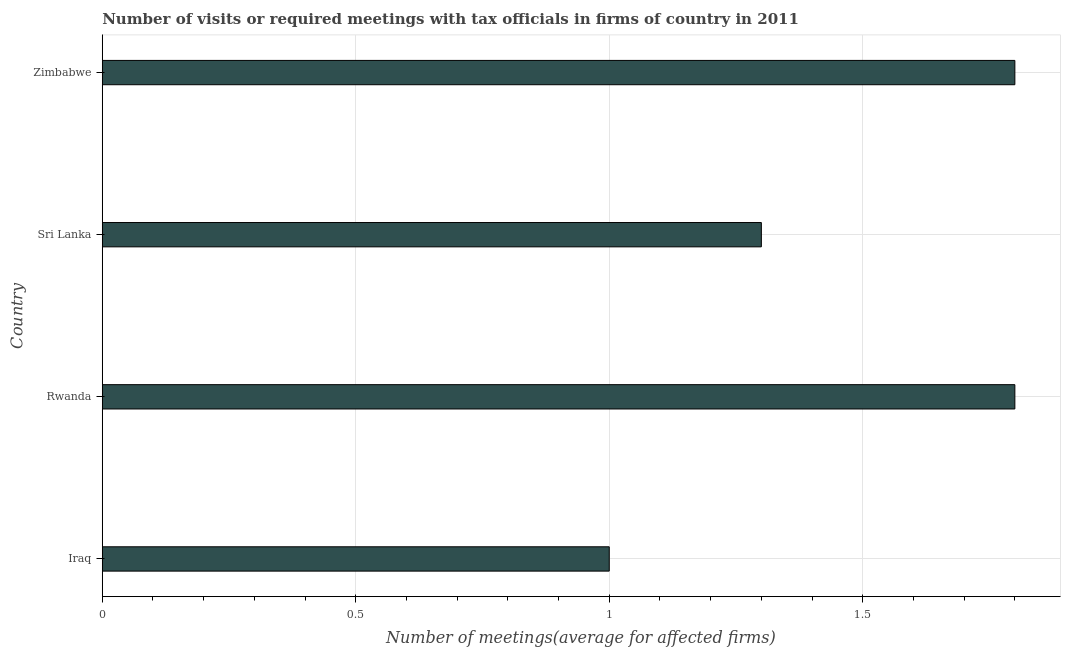Does the graph contain any zero values?
Provide a short and direct response. No. What is the title of the graph?
Your answer should be compact. Number of visits or required meetings with tax officials in firms of country in 2011. What is the label or title of the X-axis?
Keep it short and to the point. Number of meetings(average for affected firms). Across all countries, what is the minimum number of required meetings with tax officials?
Your answer should be compact. 1. In which country was the number of required meetings with tax officials maximum?
Your answer should be very brief. Rwanda. In which country was the number of required meetings with tax officials minimum?
Give a very brief answer. Iraq. What is the sum of the number of required meetings with tax officials?
Give a very brief answer. 5.9. What is the average number of required meetings with tax officials per country?
Your answer should be compact. 1.48. What is the median number of required meetings with tax officials?
Give a very brief answer. 1.55. What is the ratio of the number of required meetings with tax officials in Iraq to that in Rwanda?
Provide a short and direct response. 0.56. What is the difference between the highest and the second highest number of required meetings with tax officials?
Offer a very short reply. 0. Is the sum of the number of required meetings with tax officials in Iraq and Zimbabwe greater than the maximum number of required meetings with tax officials across all countries?
Give a very brief answer. Yes. In how many countries, is the number of required meetings with tax officials greater than the average number of required meetings with tax officials taken over all countries?
Your response must be concise. 2. How many countries are there in the graph?
Ensure brevity in your answer.  4. What is the difference between two consecutive major ticks on the X-axis?
Make the answer very short. 0.5. Are the values on the major ticks of X-axis written in scientific E-notation?
Your answer should be very brief. No. What is the Number of meetings(average for affected firms) in Rwanda?
Make the answer very short. 1.8. What is the Number of meetings(average for affected firms) in Sri Lanka?
Provide a succinct answer. 1.3. What is the difference between the Number of meetings(average for affected firms) in Iraq and Sri Lanka?
Your answer should be compact. -0.3. What is the difference between the Number of meetings(average for affected firms) in Rwanda and Zimbabwe?
Offer a very short reply. 0. What is the ratio of the Number of meetings(average for affected firms) in Iraq to that in Rwanda?
Ensure brevity in your answer.  0.56. What is the ratio of the Number of meetings(average for affected firms) in Iraq to that in Sri Lanka?
Provide a succinct answer. 0.77. What is the ratio of the Number of meetings(average for affected firms) in Iraq to that in Zimbabwe?
Give a very brief answer. 0.56. What is the ratio of the Number of meetings(average for affected firms) in Rwanda to that in Sri Lanka?
Give a very brief answer. 1.39. What is the ratio of the Number of meetings(average for affected firms) in Rwanda to that in Zimbabwe?
Provide a short and direct response. 1. What is the ratio of the Number of meetings(average for affected firms) in Sri Lanka to that in Zimbabwe?
Ensure brevity in your answer.  0.72. 